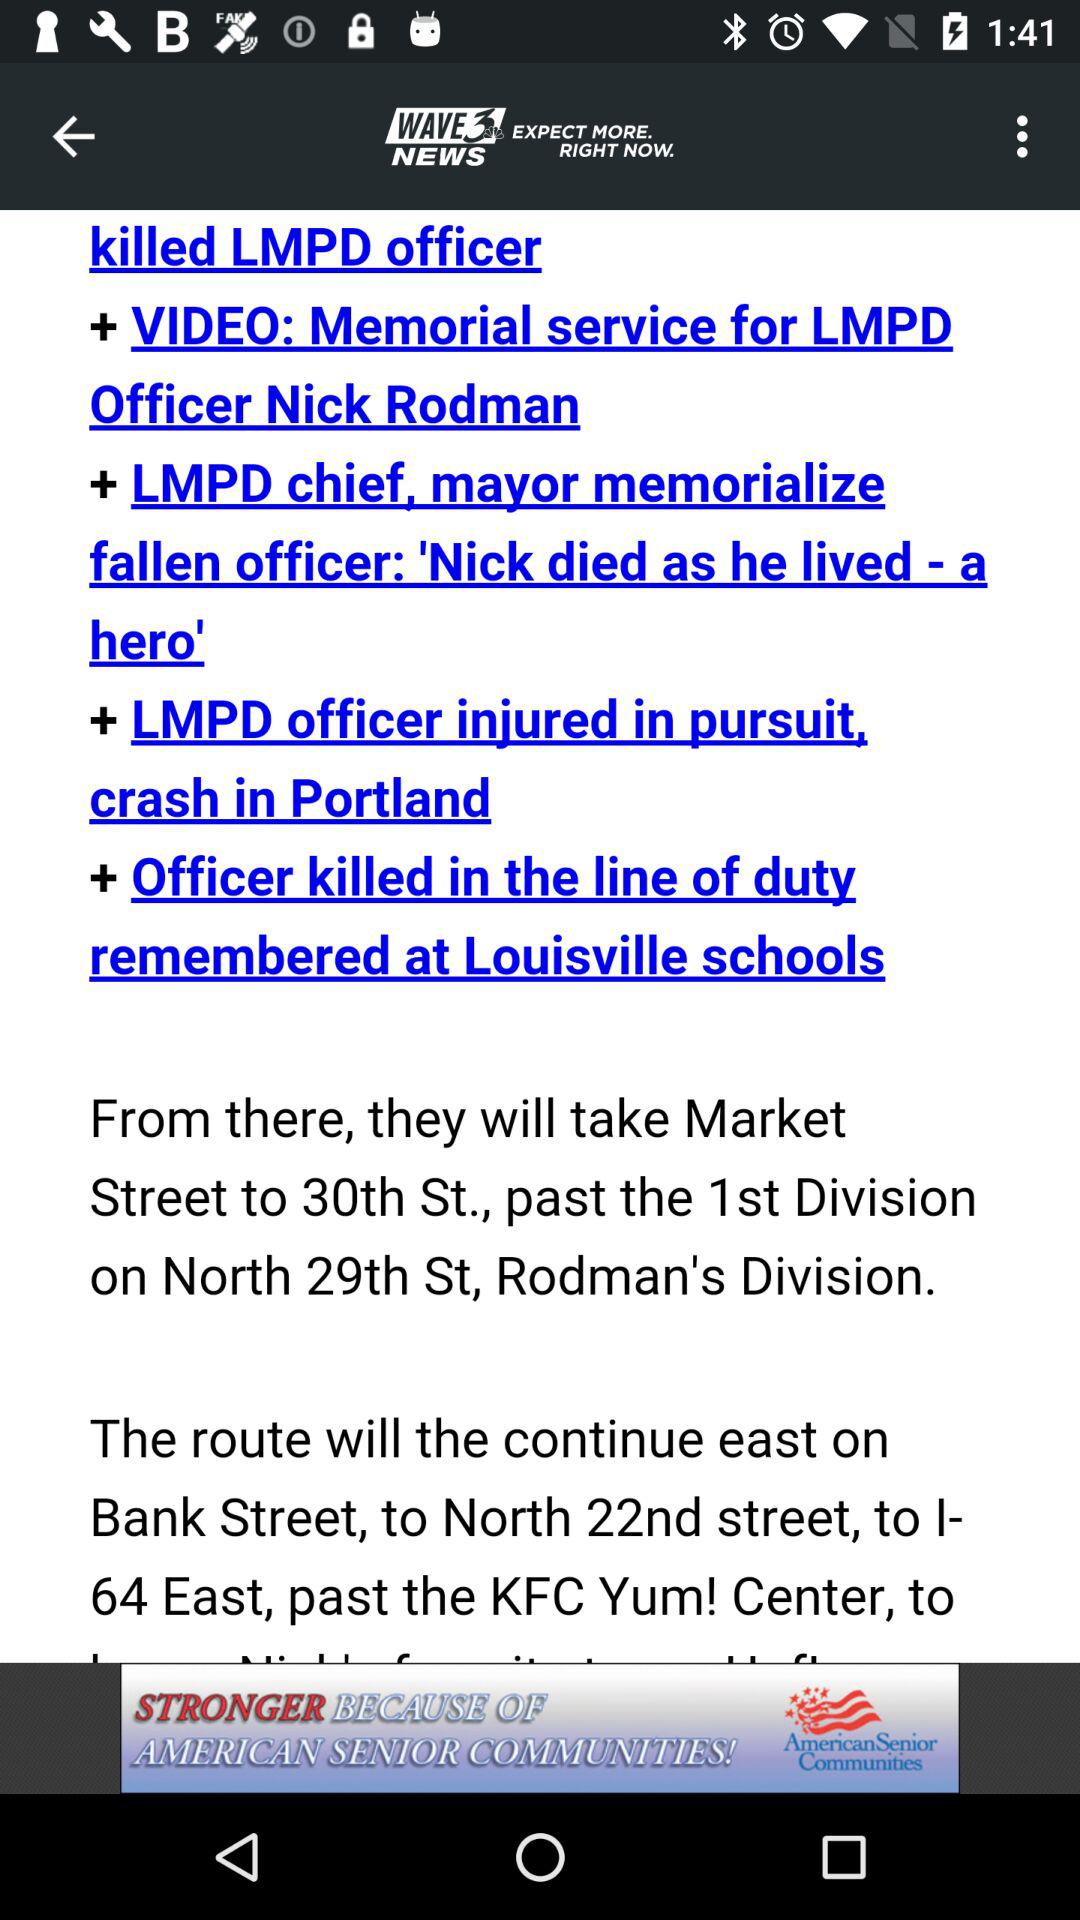What is the name of the application? The name of the application is "WAVE 3 NEWS". 